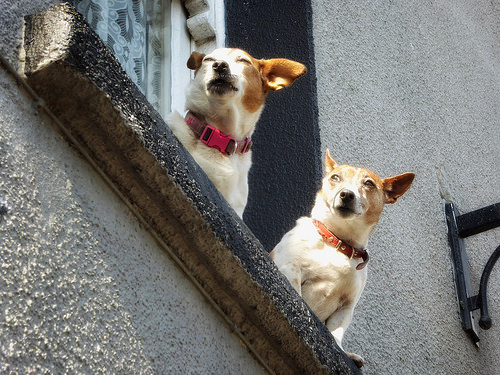<image>
Is there a dog on the wall? No. The dog is not positioned on the wall. They may be near each other, but the dog is not supported by or resting on top of the wall. Is there a dog above the dog? No. The dog is not positioned above the dog. The vertical arrangement shows a different relationship. 